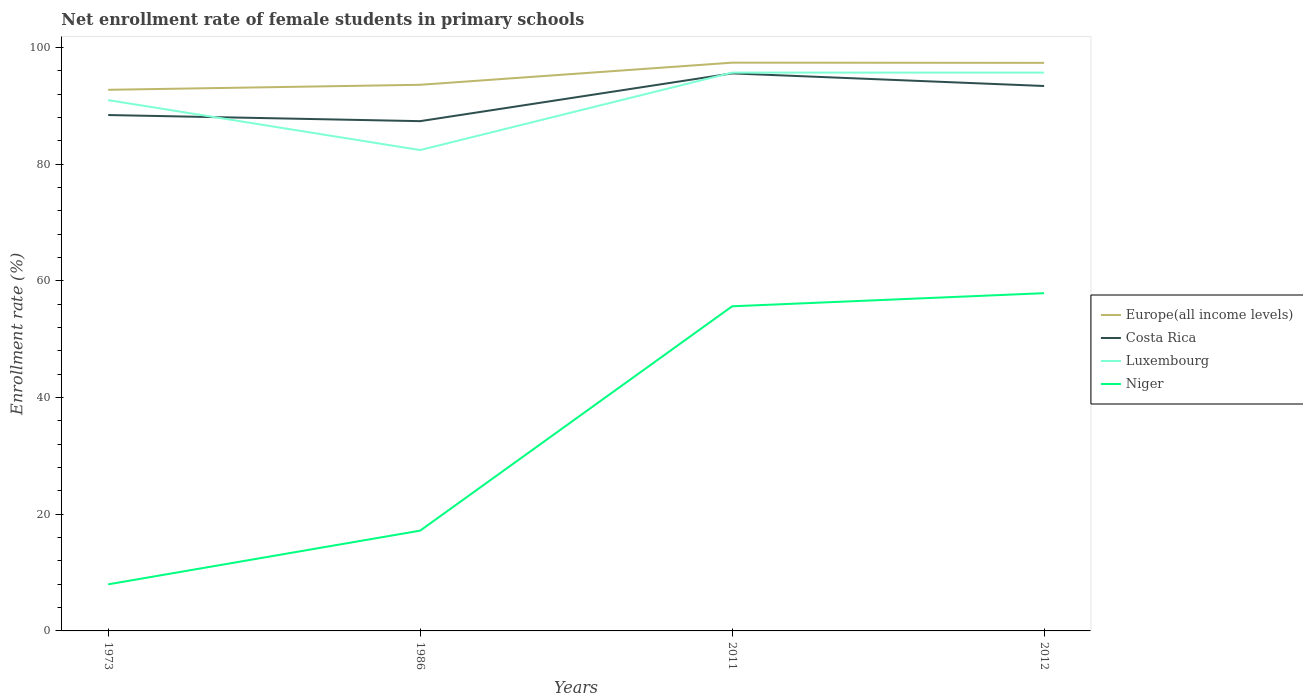How many different coloured lines are there?
Your response must be concise. 4. Does the line corresponding to Niger intersect with the line corresponding to Luxembourg?
Offer a very short reply. No. Across all years, what is the maximum net enrollment rate of female students in primary schools in Costa Rica?
Keep it short and to the point. 87.35. What is the total net enrollment rate of female students in primary schools in Costa Rica in the graph?
Your response must be concise. -7.13. What is the difference between the highest and the second highest net enrollment rate of female students in primary schools in Niger?
Offer a terse response. 49.89. What is the difference between the highest and the lowest net enrollment rate of female students in primary schools in Luxembourg?
Make the answer very short. 2. Is the net enrollment rate of female students in primary schools in Costa Rica strictly greater than the net enrollment rate of female students in primary schools in Europe(all income levels) over the years?
Your answer should be very brief. Yes. How many lines are there?
Offer a very short reply. 4. What is the difference between two consecutive major ticks on the Y-axis?
Make the answer very short. 20. Are the values on the major ticks of Y-axis written in scientific E-notation?
Offer a terse response. No. Does the graph contain any zero values?
Ensure brevity in your answer.  No. Does the graph contain grids?
Keep it short and to the point. No. How many legend labels are there?
Provide a short and direct response. 4. How are the legend labels stacked?
Offer a very short reply. Vertical. What is the title of the graph?
Your response must be concise. Net enrollment rate of female students in primary schools. What is the label or title of the Y-axis?
Offer a terse response. Enrollment rate (%). What is the Enrollment rate (%) of Europe(all income levels) in 1973?
Your answer should be compact. 92.72. What is the Enrollment rate (%) of Costa Rica in 1973?
Your response must be concise. 88.4. What is the Enrollment rate (%) in Luxembourg in 1973?
Offer a terse response. 90.95. What is the Enrollment rate (%) in Niger in 1973?
Offer a terse response. 7.98. What is the Enrollment rate (%) of Europe(all income levels) in 1986?
Keep it short and to the point. 93.58. What is the Enrollment rate (%) of Costa Rica in 1986?
Offer a very short reply. 87.35. What is the Enrollment rate (%) of Luxembourg in 1986?
Make the answer very short. 82.4. What is the Enrollment rate (%) of Niger in 1986?
Your response must be concise. 17.18. What is the Enrollment rate (%) of Europe(all income levels) in 2011?
Provide a succinct answer. 97.37. What is the Enrollment rate (%) in Costa Rica in 2011?
Give a very brief answer. 95.53. What is the Enrollment rate (%) of Luxembourg in 2011?
Offer a terse response. 95.67. What is the Enrollment rate (%) in Niger in 2011?
Your response must be concise. 55.62. What is the Enrollment rate (%) in Europe(all income levels) in 2012?
Offer a terse response. 97.34. What is the Enrollment rate (%) of Costa Rica in 2012?
Make the answer very short. 93.37. What is the Enrollment rate (%) of Luxembourg in 2012?
Offer a terse response. 95.67. What is the Enrollment rate (%) in Niger in 2012?
Ensure brevity in your answer.  57.87. Across all years, what is the maximum Enrollment rate (%) in Europe(all income levels)?
Your response must be concise. 97.37. Across all years, what is the maximum Enrollment rate (%) of Costa Rica?
Offer a terse response. 95.53. Across all years, what is the maximum Enrollment rate (%) in Luxembourg?
Keep it short and to the point. 95.67. Across all years, what is the maximum Enrollment rate (%) in Niger?
Make the answer very short. 57.87. Across all years, what is the minimum Enrollment rate (%) of Europe(all income levels)?
Your answer should be compact. 92.72. Across all years, what is the minimum Enrollment rate (%) of Costa Rica?
Your response must be concise. 87.35. Across all years, what is the minimum Enrollment rate (%) of Luxembourg?
Your answer should be very brief. 82.4. Across all years, what is the minimum Enrollment rate (%) of Niger?
Make the answer very short. 7.98. What is the total Enrollment rate (%) of Europe(all income levels) in the graph?
Keep it short and to the point. 381.01. What is the total Enrollment rate (%) of Costa Rica in the graph?
Make the answer very short. 364.66. What is the total Enrollment rate (%) of Luxembourg in the graph?
Offer a terse response. 364.69. What is the total Enrollment rate (%) in Niger in the graph?
Ensure brevity in your answer.  138.66. What is the difference between the Enrollment rate (%) in Europe(all income levels) in 1973 and that in 1986?
Offer a very short reply. -0.86. What is the difference between the Enrollment rate (%) of Costa Rica in 1973 and that in 1986?
Give a very brief answer. 1.05. What is the difference between the Enrollment rate (%) in Luxembourg in 1973 and that in 1986?
Your answer should be very brief. 8.56. What is the difference between the Enrollment rate (%) of Niger in 1973 and that in 1986?
Your answer should be very brief. -9.2. What is the difference between the Enrollment rate (%) of Europe(all income levels) in 1973 and that in 2011?
Offer a very short reply. -4.65. What is the difference between the Enrollment rate (%) in Costa Rica in 1973 and that in 2011?
Keep it short and to the point. -7.13. What is the difference between the Enrollment rate (%) in Luxembourg in 1973 and that in 2011?
Give a very brief answer. -4.71. What is the difference between the Enrollment rate (%) of Niger in 1973 and that in 2011?
Provide a succinct answer. -47.64. What is the difference between the Enrollment rate (%) of Europe(all income levels) in 1973 and that in 2012?
Your answer should be very brief. -4.62. What is the difference between the Enrollment rate (%) of Costa Rica in 1973 and that in 2012?
Offer a very short reply. -4.97. What is the difference between the Enrollment rate (%) of Luxembourg in 1973 and that in 2012?
Give a very brief answer. -4.71. What is the difference between the Enrollment rate (%) of Niger in 1973 and that in 2012?
Your answer should be very brief. -49.89. What is the difference between the Enrollment rate (%) in Europe(all income levels) in 1986 and that in 2011?
Make the answer very short. -3.79. What is the difference between the Enrollment rate (%) in Costa Rica in 1986 and that in 2011?
Give a very brief answer. -8.18. What is the difference between the Enrollment rate (%) of Luxembourg in 1986 and that in 2011?
Offer a terse response. -13.27. What is the difference between the Enrollment rate (%) of Niger in 1986 and that in 2011?
Give a very brief answer. -38.44. What is the difference between the Enrollment rate (%) of Europe(all income levels) in 1986 and that in 2012?
Your response must be concise. -3.76. What is the difference between the Enrollment rate (%) of Costa Rica in 1986 and that in 2012?
Your response must be concise. -6.02. What is the difference between the Enrollment rate (%) in Luxembourg in 1986 and that in 2012?
Give a very brief answer. -13.27. What is the difference between the Enrollment rate (%) in Niger in 1986 and that in 2012?
Your answer should be compact. -40.69. What is the difference between the Enrollment rate (%) of Europe(all income levels) in 2011 and that in 2012?
Provide a succinct answer. 0.03. What is the difference between the Enrollment rate (%) of Costa Rica in 2011 and that in 2012?
Your answer should be very brief. 2.16. What is the difference between the Enrollment rate (%) in Luxembourg in 2011 and that in 2012?
Offer a very short reply. -0. What is the difference between the Enrollment rate (%) in Niger in 2011 and that in 2012?
Ensure brevity in your answer.  -2.25. What is the difference between the Enrollment rate (%) of Europe(all income levels) in 1973 and the Enrollment rate (%) of Costa Rica in 1986?
Ensure brevity in your answer.  5.37. What is the difference between the Enrollment rate (%) in Europe(all income levels) in 1973 and the Enrollment rate (%) in Luxembourg in 1986?
Ensure brevity in your answer.  10.33. What is the difference between the Enrollment rate (%) in Europe(all income levels) in 1973 and the Enrollment rate (%) in Niger in 1986?
Make the answer very short. 75.54. What is the difference between the Enrollment rate (%) in Costa Rica in 1973 and the Enrollment rate (%) in Luxembourg in 1986?
Give a very brief answer. 6. What is the difference between the Enrollment rate (%) in Costa Rica in 1973 and the Enrollment rate (%) in Niger in 1986?
Your answer should be compact. 71.22. What is the difference between the Enrollment rate (%) in Luxembourg in 1973 and the Enrollment rate (%) in Niger in 1986?
Your answer should be very brief. 73.77. What is the difference between the Enrollment rate (%) of Europe(all income levels) in 1973 and the Enrollment rate (%) of Costa Rica in 2011?
Provide a short and direct response. -2.81. What is the difference between the Enrollment rate (%) in Europe(all income levels) in 1973 and the Enrollment rate (%) in Luxembourg in 2011?
Your answer should be very brief. -2.94. What is the difference between the Enrollment rate (%) in Europe(all income levels) in 1973 and the Enrollment rate (%) in Niger in 2011?
Keep it short and to the point. 37.1. What is the difference between the Enrollment rate (%) of Costa Rica in 1973 and the Enrollment rate (%) of Luxembourg in 2011?
Offer a very short reply. -7.27. What is the difference between the Enrollment rate (%) in Costa Rica in 1973 and the Enrollment rate (%) in Niger in 2011?
Your answer should be compact. 32.78. What is the difference between the Enrollment rate (%) in Luxembourg in 1973 and the Enrollment rate (%) in Niger in 2011?
Your response must be concise. 35.33. What is the difference between the Enrollment rate (%) in Europe(all income levels) in 1973 and the Enrollment rate (%) in Costa Rica in 2012?
Offer a very short reply. -0.65. What is the difference between the Enrollment rate (%) of Europe(all income levels) in 1973 and the Enrollment rate (%) of Luxembourg in 2012?
Your response must be concise. -2.95. What is the difference between the Enrollment rate (%) of Europe(all income levels) in 1973 and the Enrollment rate (%) of Niger in 2012?
Offer a very short reply. 34.85. What is the difference between the Enrollment rate (%) of Costa Rica in 1973 and the Enrollment rate (%) of Luxembourg in 2012?
Keep it short and to the point. -7.27. What is the difference between the Enrollment rate (%) of Costa Rica in 1973 and the Enrollment rate (%) of Niger in 2012?
Your answer should be very brief. 30.53. What is the difference between the Enrollment rate (%) in Luxembourg in 1973 and the Enrollment rate (%) in Niger in 2012?
Your response must be concise. 33.08. What is the difference between the Enrollment rate (%) of Europe(all income levels) in 1986 and the Enrollment rate (%) of Costa Rica in 2011?
Give a very brief answer. -1.95. What is the difference between the Enrollment rate (%) in Europe(all income levels) in 1986 and the Enrollment rate (%) in Luxembourg in 2011?
Keep it short and to the point. -2.09. What is the difference between the Enrollment rate (%) of Europe(all income levels) in 1986 and the Enrollment rate (%) of Niger in 2011?
Your answer should be very brief. 37.96. What is the difference between the Enrollment rate (%) in Costa Rica in 1986 and the Enrollment rate (%) in Luxembourg in 2011?
Ensure brevity in your answer.  -8.32. What is the difference between the Enrollment rate (%) in Costa Rica in 1986 and the Enrollment rate (%) in Niger in 2011?
Provide a short and direct response. 31.73. What is the difference between the Enrollment rate (%) of Luxembourg in 1986 and the Enrollment rate (%) of Niger in 2011?
Provide a short and direct response. 26.77. What is the difference between the Enrollment rate (%) of Europe(all income levels) in 1986 and the Enrollment rate (%) of Costa Rica in 2012?
Offer a terse response. 0.2. What is the difference between the Enrollment rate (%) of Europe(all income levels) in 1986 and the Enrollment rate (%) of Luxembourg in 2012?
Provide a short and direct response. -2.09. What is the difference between the Enrollment rate (%) in Europe(all income levels) in 1986 and the Enrollment rate (%) in Niger in 2012?
Provide a short and direct response. 35.71. What is the difference between the Enrollment rate (%) of Costa Rica in 1986 and the Enrollment rate (%) of Luxembourg in 2012?
Ensure brevity in your answer.  -8.32. What is the difference between the Enrollment rate (%) in Costa Rica in 1986 and the Enrollment rate (%) in Niger in 2012?
Your answer should be compact. 29.48. What is the difference between the Enrollment rate (%) in Luxembourg in 1986 and the Enrollment rate (%) in Niger in 2012?
Keep it short and to the point. 24.52. What is the difference between the Enrollment rate (%) of Europe(all income levels) in 2011 and the Enrollment rate (%) of Costa Rica in 2012?
Your answer should be compact. 4. What is the difference between the Enrollment rate (%) in Europe(all income levels) in 2011 and the Enrollment rate (%) in Luxembourg in 2012?
Your answer should be compact. 1.7. What is the difference between the Enrollment rate (%) in Europe(all income levels) in 2011 and the Enrollment rate (%) in Niger in 2012?
Provide a short and direct response. 39.5. What is the difference between the Enrollment rate (%) in Costa Rica in 2011 and the Enrollment rate (%) in Luxembourg in 2012?
Offer a very short reply. -0.13. What is the difference between the Enrollment rate (%) in Costa Rica in 2011 and the Enrollment rate (%) in Niger in 2012?
Your answer should be compact. 37.66. What is the difference between the Enrollment rate (%) of Luxembourg in 2011 and the Enrollment rate (%) of Niger in 2012?
Your response must be concise. 37.79. What is the average Enrollment rate (%) in Europe(all income levels) per year?
Provide a short and direct response. 95.25. What is the average Enrollment rate (%) in Costa Rica per year?
Keep it short and to the point. 91.16. What is the average Enrollment rate (%) of Luxembourg per year?
Keep it short and to the point. 91.17. What is the average Enrollment rate (%) in Niger per year?
Offer a very short reply. 34.67. In the year 1973, what is the difference between the Enrollment rate (%) in Europe(all income levels) and Enrollment rate (%) in Costa Rica?
Your answer should be very brief. 4.32. In the year 1973, what is the difference between the Enrollment rate (%) in Europe(all income levels) and Enrollment rate (%) in Luxembourg?
Give a very brief answer. 1.77. In the year 1973, what is the difference between the Enrollment rate (%) in Europe(all income levels) and Enrollment rate (%) in Niger?
Make the answer very short. 84.74. In the year 1973, what is the difference between the Enrollment rate (%) of Costa Rica and Enrollment rate (%) of Luxembourg?
Give a very brief answer. -2.56. In the year 1973, what is the difference between the Enrollment rate (%) of Costa Rica and Enrollment rate (%) of Niger?
Keep it short and to the point. 80.42. In the year 1973, what is the difference between the Enrollment rate (%) of Luxembourg and Enrollment rate (%) of Niger?
Ensure brevity in your answer.  82.97. In the year 1986, what is the difference between the Enrollment rate (%) of Europe(all income levels) and Enrollment rate (%) of Costa Rica?
Your response must be concise. 6.23. In the year 1986, what is the difference between the Enrollment rate (%) of Europe(all income levels) and Enrollment rate (%) of Luxembourg?
Your answer should be very brief. 11.18. In the year 1986, what is the difference between the Enrollment rate (%) in Europe(all income levels) and Enrollment rate (%) in Niger?
Offer a very short reply. 76.4. In the year 1986, what is the difference between the Enrollment rate (%) of Costa Rica and Enrollment rate (%) of Luxembourg?
Provide a succinct answer. 4.95. In the year 1986, what is the difference between the Enrollment rate (%) of Costa Rica and Enrollment rate (%) of Niger?
Your answer should be compact. 70.17. In the year 1986, what is the difference between the Enrollment rate (%) of Luxembourg and Enrollment rate (%) of Niger?
Your answer should be compact. 65.21. In the year 2011, what is the difference between the Enrollment rate (%) of Europe(all income levels) and Enrollment rate (%) of Costa Rica?
Offer a terse response. 1.84. In the year 2011, what is the difference between the Enrollment rate (%) of Europe(all income levels) and Enrollment rate (%) of Luxembourg?
Make the answer very short. 1.71. In the year 2011, what is the difference between the Enrollment rate (%) in Europe(all income levels) and Enrollment rate (%) in Niger?
Ensure brevity in your answer.  41.75. In the year 2011, what is the difference between the Enrollment rate (%) in Costa Rica and Enrollment rate (%) in Luxembourg?
Make the answer very short. -0.13. In the year 2011, what is the difference between the Enrollment rate (%) of Costa Rica and Enrollment rate (%) of Niger?
Provide a short and direct response. 39.91. In the year 2011, what is the difference between the Enrollment rate (%) of Luxembourg and Enrollment rate (%) of Niger?
Offer a very short reply. 40.04. In the year 2012, what is the difference between the Enrollment rate (%) of Europe(all income levels) and Enrollment rate (%) of Costa Rica?
Provide a short and direct response. 3.97. In the year 2012, what is the difference between the Enrollment rate (%) in Europe(all income levels) and Enrollment rate (%) in Luxembourg?
Make the answer very short. 1.67. In the year 2012, what is the difference between the Enrollment rate (%) of Europe(all income levels) and Enrollment rate (%) of Niger?
Offer a terse response. 39.47. In the year 2012, what is the difference between the Enrollment rate (%) in Costa Rica and Enrollment rate (%) in Luxembourg?
Ensure brevity in your answer.  -2.29. In the year 2012, what is the difference between the Enrollment rate (%) of Costa Rica and Enrollment rate (%) of Niger?
Your answer should be compact. 35.5. In the year 2012, what is the difference between the Enrollment rate (%) in Luxembourg and Enrollment rate (%) in Niger?
Offer a terse response. 37.8. What is the ratio of the Enrollment rate (%) of Europe(all income levels) in 1973 to that in 1986?
Make the answer very short. 0.99. What is the ratio of the Enrollment rate (%) of Luxembourg in 1973 to that in 1986?
Ensure brevity in your answer.  1.1. What is the ratio of the Enrollment rate (%) of Niger in 1973 to that in 1986?
Ensure brevity in your answer.  0.46. What is the ratio of the Enrollment rate (%) of Europe(all income levels) in 1973 to that in 2011?
Your response must be concise. 0.95. What is the ratio of the Enrollment rate (%) in Costa Rica in 1973 to that in 2011?
Your answer should be compact. 0.93. What is the ratio of the Enrollment rate (%) of Luxembourg in 1973 to that in 2011?
Provide a short and direct response. 0.95. What is the ratio of the Enrollment rate (%) in Niger in 1973 to that in 2011?
Make the answer very short. 0.14. What is the ratio of the Enrollment rate (%) in Europe(all income levels) in 1973 to that in 2012?
Give a very brief answer. 0.95. What is the ratio of the Enrollment rate (%) of Costa Rica in 1973 to that in 2012?
Provide a succinct answer. 0.95. What is the ratio of the Enrollment rate (%) in Luxembourg in 1973 to that in 2012?
Offer a very short reply. 0.95. What is the ratio of the Enrollment rate (%) in Niger in 1973 to that in 2012?
Offer a very short reply. 0.14. What is the ratio of the Enrollment rate (%) of Europe(all income levels) in 1986 to that in 2011?
Provide a succinct answer. 0.96. What is the ratio of the Enrollment rate (%) of Costa Rica in 1986 to that in 2011?
Provide a succinct answer. 0.91. What is the ratio of the Enrollment rate (%) of Luxembourg in 1986 to that in 2011?
Keep it short and to the point. 0.86. What is the ratio of the Enrollment rate (%) of Niger in 1986 to that in 2011?
Offer a terse response. 0.31. What is the ratio of the Enrollment rate (%) of Europe(all income levels) in 1986 to that in 2012?
Provide a short and direct response. 0.96. What is the ratio of the Enrollment rate (%) in Costa Rica in 1986 to that in 2012?
Offer a terse response. 0.94. What is the ratio of the Enrollment rate (%) of Luxembourg in 1986 to that in 2012?
Provide a short and direct response. 0.86. What is the ratio of the Enrollment rate (%) in Niger in 1986 to that in 2012?
Offer a terse response. 0.3. What is the ratio of the Enrollment rate (%) in Costa Rica in 2011 to that in 2012?
Give a very brief answer. 1.02. What is the ratio of the Enrollment rate (%) of Luxembourg in 2011 to that in 2012?
Provide a succinct answer. 1. What is the ratio of the Enrollment rate (%) of Niger in 2011 to that in 2012?
Your answer should be very brief. 0.96. What is the difference between the highest and the second highest Enrollment rate (%) of Europe(all income levels)?
Your answer should be compact. 0.03. What is the difference between the highest and the second highest Enrollment rate (%) of Costa Rica?
Your answer should be very brief. 2.16. What is the difference between the highest and the second highest Enrollment rate (%) of Luxembourg?
Your response must be concise. 0. What is the difference between the highest and the second highest Enrollment rate (%) of Niger?
Provide a short and direct response. 2.25. What is the difference between the highest and the lowest Enrollment rate (%) of Europe(all income levels)?
Your answer should be very brief. 4.65. What is the difference between the highest and the lowest Enrollment rate (%) of Costa Rica?
Provide a short and direct response. 8.18. What is the difference between the highest and the lowest Enrollment rate (%) of Luxembourg?
Your answer should be compact. 13.27. What is the difference between the highest and the lowest Enrollment rate (%) of Niger?
Your answer should be compact. 49.89. 